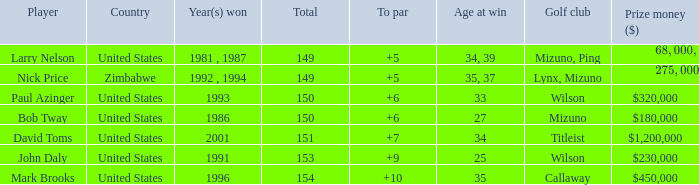Could you parse the entire table as a dict? {'header': ['Player', 'Country', 'Year(s) won', 'Total', 'To par', 'Age at win', 'Golf club', 'Prize money ($)'], 'rows': [['Larry Nelson', 'United States', '1981 , 1987', '149', '+5', '34, 39', 'Mizuno, Ping', '$68,000, $130,000'], ['Nick Price', 'Zimbabwe', '1992 , 1994', '149', '+5', '35, 37', 'Lynx, Mizuno', '$275,000, $300,000'], ['Paul Azinger', 'United States', '1993', '150', '+6', '33', 'Wilson', '$320,000'], ['Bob Tway', 'United States', '1986', '150', '+6', '27', 'Mizuno', '$180,000'], ['David Toms', 'United States', '2001', '151', '+7', '34', 'Titleist', '$1,200,000'], ['John Daly', 'United States', '1991', '153', '+9', '25', 'Wilson', '$230,000'], ['Mark Brooks', 'United States', '1996', '154', '+10', '35', 'Callaway', '$450,000']]} What is the total for 1986 with a to par higher than 6? 0.0. 